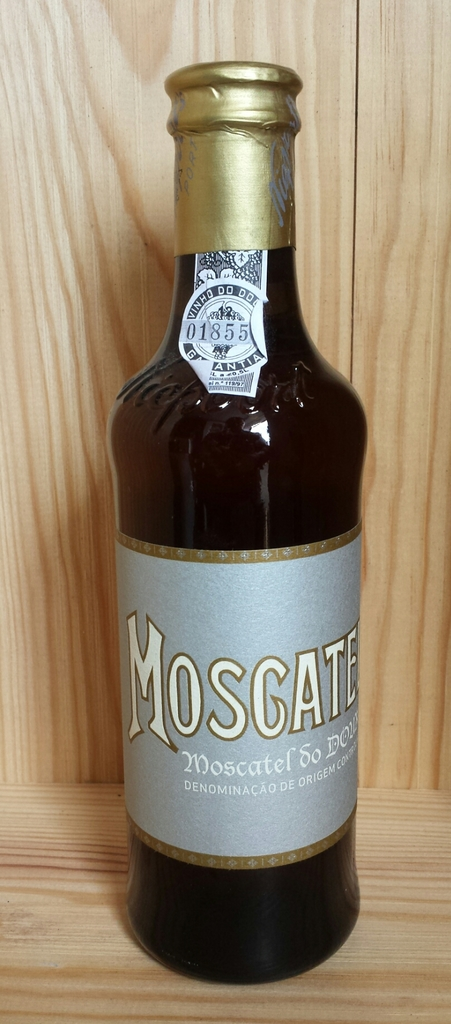Provide a one-sentence caption for the provided image. A bottle of Moscatel, identified by its distinctive gold and gray label, is showcased in a wooden cabinet, highlighting its prestigious 'Denominação de Origem Controlada' designation, a mark of quality and authenticity. 